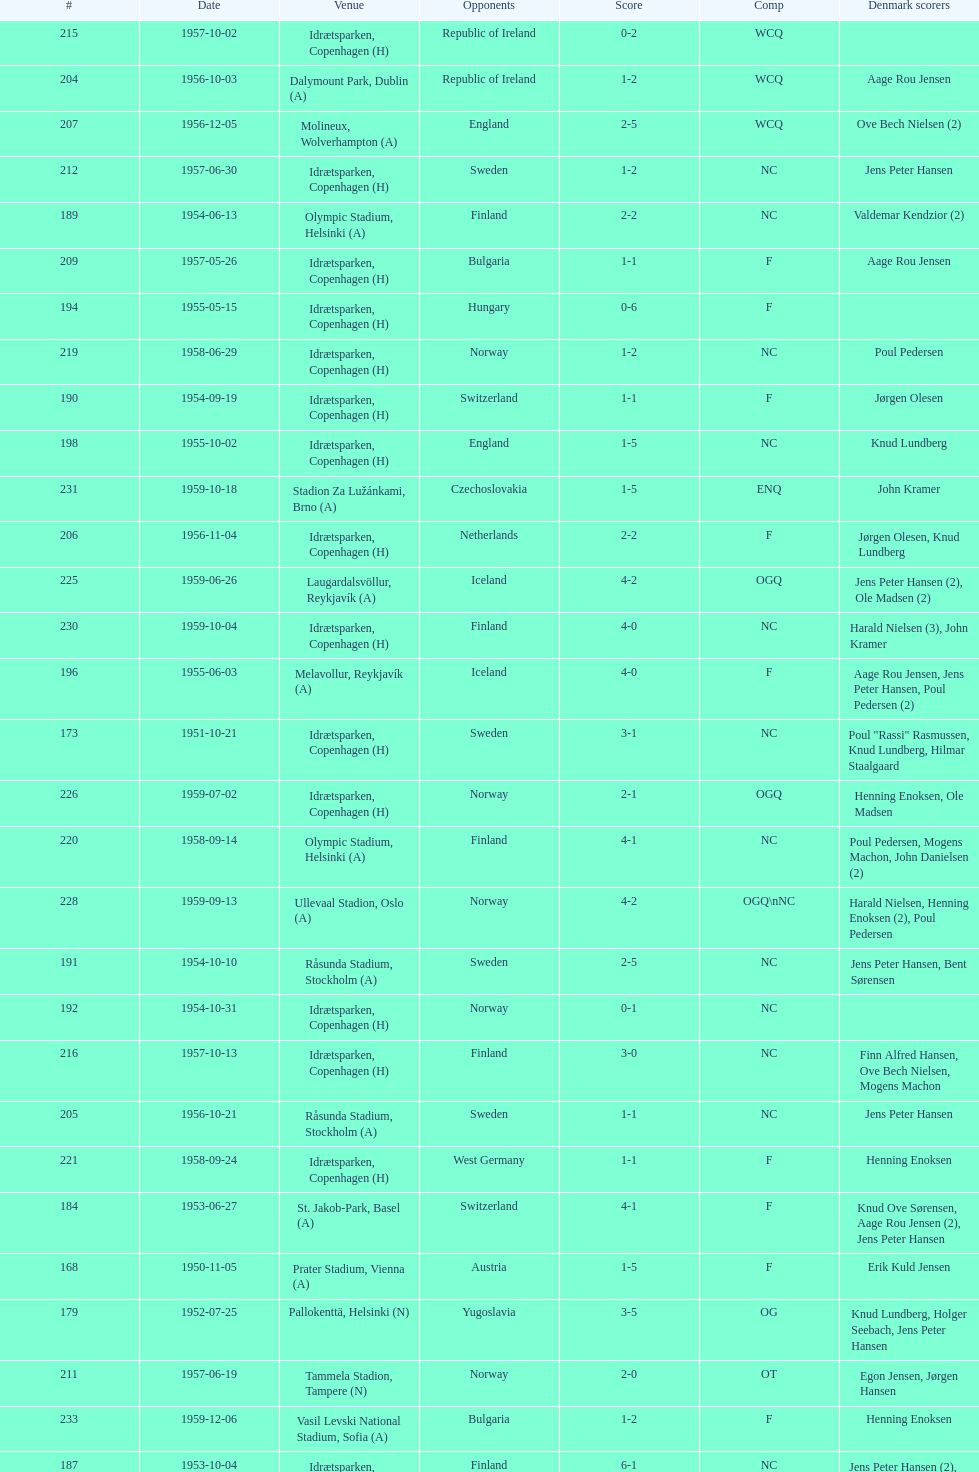What was the difference in score between the two teams in the last game? 1. 